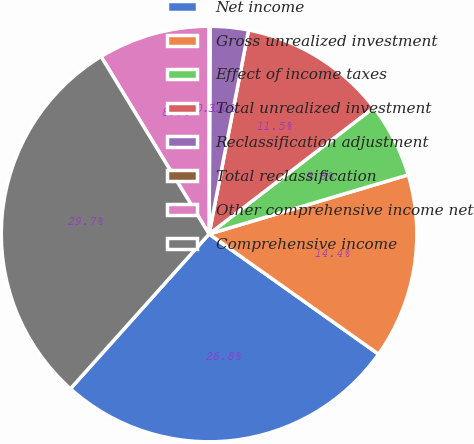Convert chart. <chart><loc_0><loc_0><loc_500><loc_500><pie_chart><fcel>Net income<fcel>Gross unrealized investment<fcel>Effect of income taxes<fcel>Total unrealized investment<fcel>Reclassification adjustment<fcel>Total reclassification<fcel>Other comprehensive income net<fcel>Comprehensive income<nl><fcel>26.81%<fcel>14.41%<fcel>5.82%<fcel>11.54%<fcel>2.96%<fcel>0.1%<fcel>8.68%<fcel>29.67%<nl></chart> 